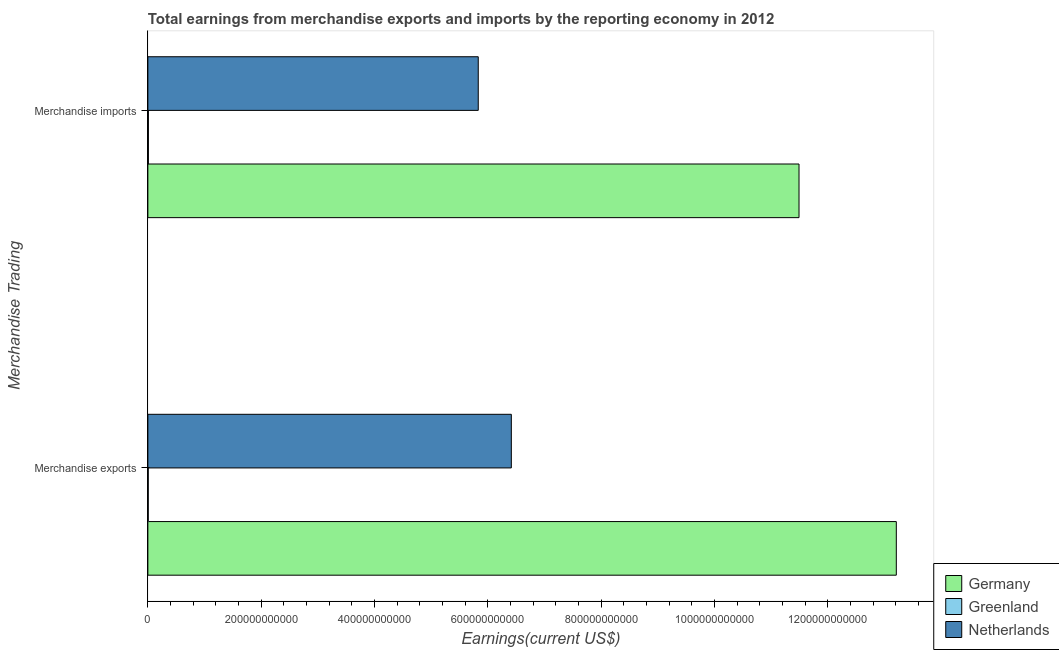How many different coloured bars are there?
Provide a short and direct response. 3. Are the number of bars per tick equal to the number of legend labels?
Your answer should be very brief. Yes. How many bars are there on the 2nd tick from the bottom?
Your answer should be very brief. 3. What is the label of the 1st group of bars from the top?
Keep it short and to the point. Merchandise imports. What is the earnings from merchandise exports in Germany?
Your answer should be very brief. 1.32e+12. Across all countries, what is the maximum earnings from merchandise imports?
Provide a succinct answer. 1.15e+12. Across all countries, what is the minimum earnings from merchandise imports?
Provide a succinct answer. 9.24e+08. In which country was the earnings from merchandise exports minimum?
Your response must be concise. Greenland. What is the total earnings from merchandise imports in the graph?
Your response must be concise. 1.73e+12. What is the difference between the earnings from merchandise exports in Germany and that in Greenland?
Make the answer very short. 1.32e+12. What is the difference between the earnings from merchandise exports in Greenland and the earnings from merchandise imports in Germany?
Your answer should be very brief. -1.15e+12. What is the average earnings from merchandise exports per country?
Your answer should be compact. 6.54e+11. What is the difference between the earnings from merchandise imports and earnings from merchandise exports in Greenland?
Your response must be concise. 2.67e+08. In how many countries, is the earnings from merchandise exports greater than 600000000000 US$?
Give a very brief answer. 2. What is the ratio of the earnings from merchandise exports in Netherlands to that in Greenland?
Offer a very short reply. 975.59. Is the earnings from merchandise exports in Germany less than that in Greenland?
Your response must be concise. No. What does the 1st bar from the top in Merchandise imports represents?
Offer a very short reply. Netherlands. Are all the bars in the graph horizontal?
Keep it short and to the point. Yes. How many countries are there in the graph?
Offer a terse response. 3. What is the difference between two consecutive major ticks on the X-axis?
Provide a succinct answer. 2.00e+11. Are the values on the major ticks of X-axis written in scientific E-notation?
Ensure brevity in your answer.  No. Where does the legend appear in the graph?
Ensure brevity in your answer.  Bottom right. How are the legend labels stacked?
Keep it short and to the point. Vertical. What is the title of the graph?
Ensure brevity in your answer.  Total earnings from merchandise exports and imports by the reporting economy in 2012. What is the label or title of the X-axis?
Your answer should be very brief. Earnings(current US$). What is the label or title of the Y-axis?
Offer a very short reply. Merchandise Trading. What is the Earnings(current US$) of Germany in Merchandise exports?
Keep it short and to the point. 1.32e+12. What is the Earnings(current US$) of Greenland in Merchandise exports?
Provide a short and direct response. 6.57e+08. What is the Earnings(current US$) in Netherlands in Merchandise exports?
Ensure brevity in your answer.  6.41e+11. What is the Earnings(current US$) of Germany in Merchandise imports?
Provide a short and direct response. 1.15e+12. What is the Earnings(current US$) of Greenland in Merchandise imports?
Your answer should be compact. 9.24e+08. What is the Earnings(current US$) of Netherlands in Merchandise imports?
Offer a very short reply. 5.83e+11. Across all Merchandise Trading, what is the maximum Earnings(current US$) in Germany?
Ensure brevity in your answer.  1.32e+12. Across all Merchandise Trading, what is the maximum Earnings(current US$) of Greenland?
Your answer should be very brief. 9.24e+08. Across all Merchandise Trading, what is the maximum Earnings(current US$) in Netherlands?
Your answer should be compact. 6.41e+11. Across all Merchandise Trading, what is the minimum Earnings(current US$) of Germany?
Give a very brief answer. 1.15e+12. Across all Merchandise Trading, what is the minimum Earnings(current US$) in Greenland?
Offer a very short reply. 6.57e+08. Across all Merchandise Trading, what is the minimum Earnings(current US$) of Netherlands?
Make the answer very short. 5.83e+11. What is the total Earnings(current US$) of Germany in the graph?
Offer a very short reply. 2.47e+12. What is the total Earnings(current US$) in Greenland in the graph?
Your answer should be compact. 1.58e+09. What is the total Earnings(current US$) in Netherlands in the graph?
Make the answer very short. 1.22e+12. What is the difference between the Earnings(current US$) of Germany in Merchandise exports and that in Merchandise imports?
Ensure brevity in your answer.  1.72e+11. What is the difference between the Earnings(current US$) in Greenland in Merchandise exports and that in Merchandise imports?
Provide a succinct answer. -2.67e+08. What is the difference between the Earnings(current US$) of Netherlands in Merchandise exports and that in Merchandise imports?
Your answer should be compact. 5.84e+1. What is the difference between the Earnings(current US$) in Germany in Merchandise exports and the Earnings(current US$) in Greenland in Merchandise imports?
Make the answer very short. 1.32e+12. What is the difference between the Earnings(current US$) of Germany in Merchandise exports and the Earnings(current US$) of Netherlands in Merchandise imports?
Make the answer very short. 7.38e+11. What is the difference between the Earnings(current US$) of Greenland in Merchandise exports and the Earnings(current US$) of Netherlands in Merchandise imports?
Provide a succinct answer. -5.82e+11. What is the average Earnings(current US$) of Germany per Merchandise Trading?
Offer a very short reply. 1.23e+12. What is the average Earnings(current US$) of Greenland per Merchandise Trading?
Ensure brevity in your answer.  7.91e+08. What is the average Earnings(current US$) of Netherlands per Merchandise Trading?
Your answer should be compact. 6.12e+11. What is the difference between the Earnings(current US$) in Germany and Earnings(current US$) in Greenland in Merchandise exports?
Your answer should be compact. 1.32e+12. What is the difference between the Earnings(current US$) of Germany and Earnings(current US$) of Netherlands in Merchandise exports?
Your answer should be compact. 6.79e+11. What is the difference between the Earnings(current US$) of Greenland and Earnings(current US$) of Netherlands in Merchandise exports?
Your answer should be compact. -6.41e+11. What is the difference between the Earnings(current US$) of Germany and Earnings(current US$) of Greenland in Merchandise imports?
Make the answer very short. 1.15e+12. What is the difference between the Earnings(current US$) in Germany and Earnings(current US$) in Netherlands in Merchandise imports?
Provide a short and direct response. 5.66e+11. What is the difference between the Earnings(current US$) in Greenland and Earnings(current US$) in Netherlands in Merchandise imports?
Your response must be concise. -5.82e+11. What is the ratio of the Earnings(current US$) of Germany in Merchandise exports to that in Merchandise imports?
Provide a succinct answer. 1.15. What is the ratio of the Earnings(current US$) in Greenland in Merchandise exports to that in Merchandise imports?
Give a very brief answer. 0.71. What is the ratio of the Earnings(current US$) in Netherlands in Merchandise exports to that in Merchandise imports?
Your response must be concise. 1.1. What is the difference between the highest and the second highest Earnings(current US$) of Germany?
Provide a succinct answer. 1.72e+11. What is the difference between the highest and the second highest Earnings(current US$) of Greenland?
Provide a succinct answer. 2.67e+08. What is the difference between the highest and the second highest Earnings(current US$) of Netherlands?
Your answer should be compact. 5.84e+1. What is the difference between the highest and the lowest Earnings(current US$) of Germany?
Your response must be concise. 1.72e+11. What is the difference between the highest and the lowest Earnings(current US$) in Greenland?
Provide a succinct answer. 2.67e+08. What is the difference between the highest and the lowest Earnings(current US$) of Netherlands?
Your answer should be compact. 5.84e+1. 